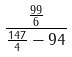Convert formula to latex. <formula><loc_0><loc_0><loc_500><loc_500>\frac { \frac { 9 9 } { 6 } } { \frac { 1 4 7 } { 4 } - 9 4 }</formula> 